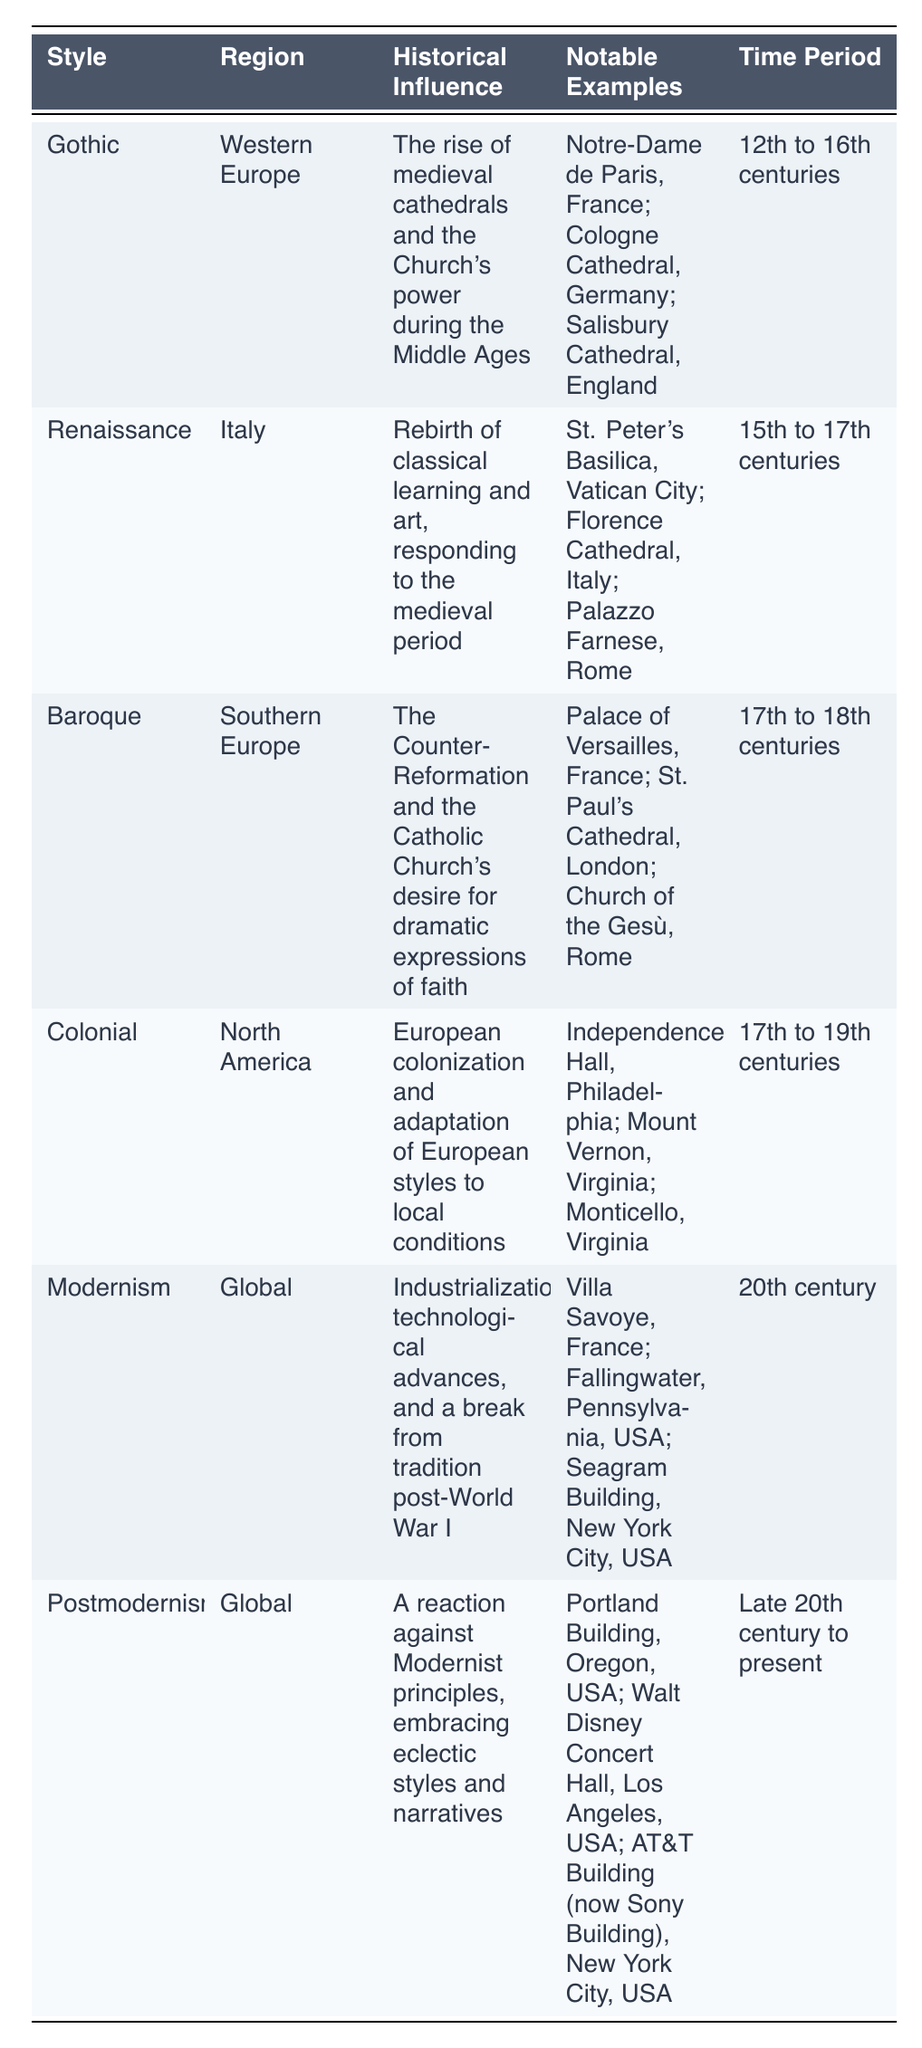What region is associated with the Gothic architectural style? The table indicates that the Gothic style is associated with "Western Europe." This information can be found directly in the corresponding row of the table.
Answer: Western Europe Which architectural style is characterized by the term "Rebirth of classical learning and art"? According to the table, the Renaissance style is defined by the historical influence stating "Rebirth of classical learning and art." This can be directly retrieved from the historical influence column for the Renaissance entry.
Answer: Renaissance What notable example of Baroque architecture is located in London? The table lists "St. Paul's Cathedral, London" as a notable example of Baroque architecture. This specific information is directly accessible in the table under the notable examples for Baroque.
Answer: St. Paul's Cathedral, London Is Modernism associated with a specific time period in the 20th century? Yes, the table explicitly states that Modernism is linked to the "20th century" as its time period. This is a clear retrieval from the table.
Answer: Yes How many architectural styles are listed in the table that are categorized as Global? Two styles are categorized as Global: Modernism and Postmodernism. By counting the regions in the table, both entries can be identified as having "Global" as their region.
Answer: 2 Which region influenced the Colonial architectural style? The Colonial architectural style is influenced by "North America" as indicated in the region column of the table. This is a straightforward retrieval from the respective row.
Answer: North America What is the time period for the Renaissance architectural style? The time period for the Renaissance style is "15th to 17th centuries," which can be directly found in the time period column of the Renaissance row.
Answer: 15th to 17th centuries Does the Baroque architectural style have historical influences related to the Catholic Church? Yes, the table shows that the Baroque style's historical influence is linked to "The Counter-Reformation and the Catholic Church's desire for dramatic expressions of faith," indicating a clear connection to the Church.
Answer: Yes Which architectural style has the most notable examples listed in the table? The styles listed each have three notable examples, which includes Gothic, Renaissance, Baroque, Colonial, Modernism, and Postmodernism. Therefore, they all share this count.
Answer: All have the same number 